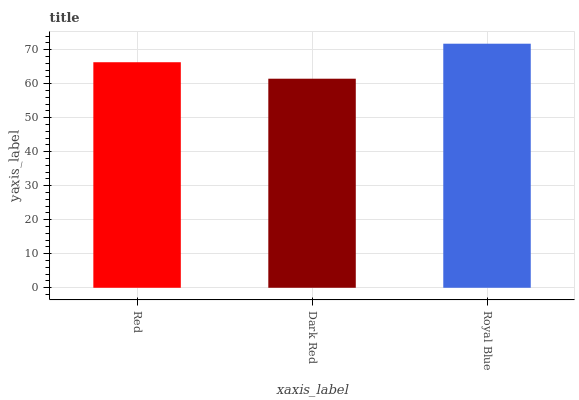Is Dark Red the minimum?
Answer yes or no. Yes. Is Royal Blue the maximum?
Answer yes or no. Yes. Is Royal Blue the minimum?
Answer yes or no. No. Is Dark Red the maximum?
Answer yes or no. No. Is Royal Blue greater than Dark Red?
Answer yes or no. Yes. Is Dark Red less than Royal Blue?
Answer yes or no. Yes. Is Dark Red greater than Royal Blue?
Answer yes or no. No. Is Royal Blue less than Dark Red?
Answer yes or no. No. Is Red the high median?
Answer yes or no. Yes. Is Red the low median?
Answer yes or no. Yes. Is Dark Red the high median?
Answer yes or no. No. Is Dark Red the low median?
Answer yes or no. No. 